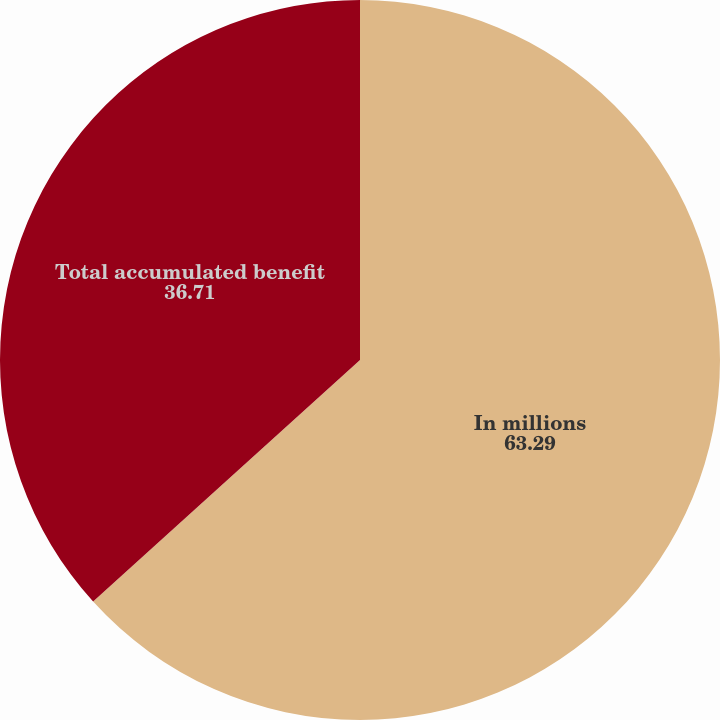<chart> <loc_0><loc_0><loc_500><loc_500><pie_chart><fcel>In millions<fcel>Total accumulated benefit<nl><fcel>63.29%<fcel>36.71%<nl></chart> 